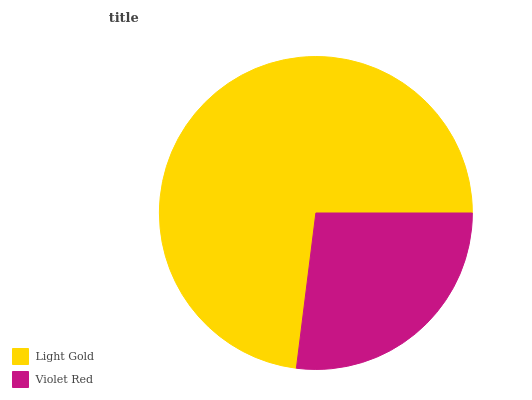Is Violet Red the minimum?
Answer yes or no. Yes. Is Light Gold the maximum?
Answer yes or no. Yes. Is Violet Red the maximum?
Answer yes or no. No. Is Light Gold greater than Violet Red?
Answer yes or no. Yes. Is Violet Red less than Light Gold?
Answer yes or no. Yes. Is Violet Red greater than Light Gold?
Answer yes or no. No. Is Light Gold less than Violet Red?
Answer yes or no. No. Is Light Gold the high median?
Answer yes or no. Yes. Is Violet Red the low median?
Answer yes or no. Yes. Is Violet Red the high median?
Answer yes or no. No. Is Light Gold the low median?
Answer yes or no. No. 